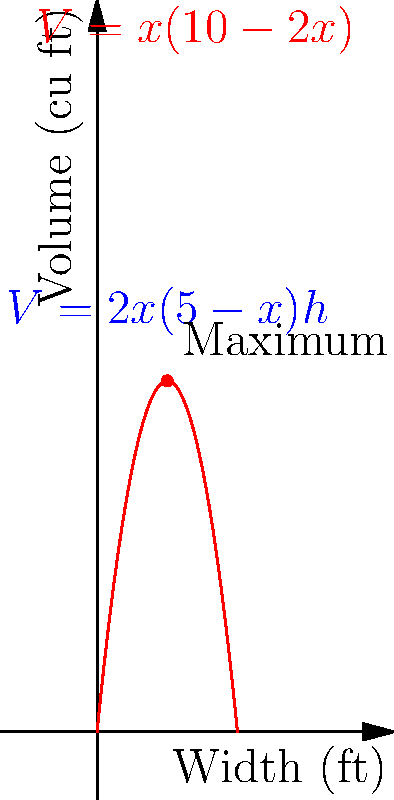You want to build a custom bookshelf to maximize storage in your small apartment. The wall space available is 5 feet wide and 8 feet high. The depth of the bookshelf is fixed at 1 foot. The volume $V$ of the bookshelf is given by $V = x(5-x)h$, where $x$ is the width of each shelf compartment and $h$ is the height. To ensure stability, the height $h$ is set to be twice the width $x$. Find the optimal width $x$ that maximizes the volume of the bookshelf. Let's approach this step-by-step:

1) Given: $V = x(5-x)h$ and $h = 2x$

2) Substitute $h = 2x$ into the volume equation:
   $V = x(5-x)(2x) = 2x^2(5-x) = 10x^2 - 2x^3$

3) To find the maximum volume, we need to find where $\frac{dV}{dx} = 0$:
   $\frac{dV}{dx} = 20x - 6x^2$

4) Set this equal to zero and solve:
   $20x - 6x^2 = 0$
   $2x(10 - 3x) = 0$
   $x = 0$ or $10 - 3x = 0$

5) $x = 0$ doesn't make sense for a bookshelf, so:
   $10 - 3x = 0$
   $3x = 10$
   $x = \frac{10}{3} \approx 3.33$ feet

6) To confirm this is a maximum, check the second derivative:
   $\frac{d^2V}{dx^2} = 20 - 12x$
   At $x = \frac{10}{3}$, $\frac{d^2V}{dx^2} = 20 - 12(\frac{10}{3}) = -20 < 0$

7) Since the second derivative is negative at this point, it confirms a maximum.

8) However, we need to consider the constraints. The wall is only 5 feet wide, so each shelf compartment can't be wider than 2.5 feet.

9) Therefore, the optimal width is 2.5 feet, which is the maximum allowed by the constraints.
Answer: 2.5 feet 